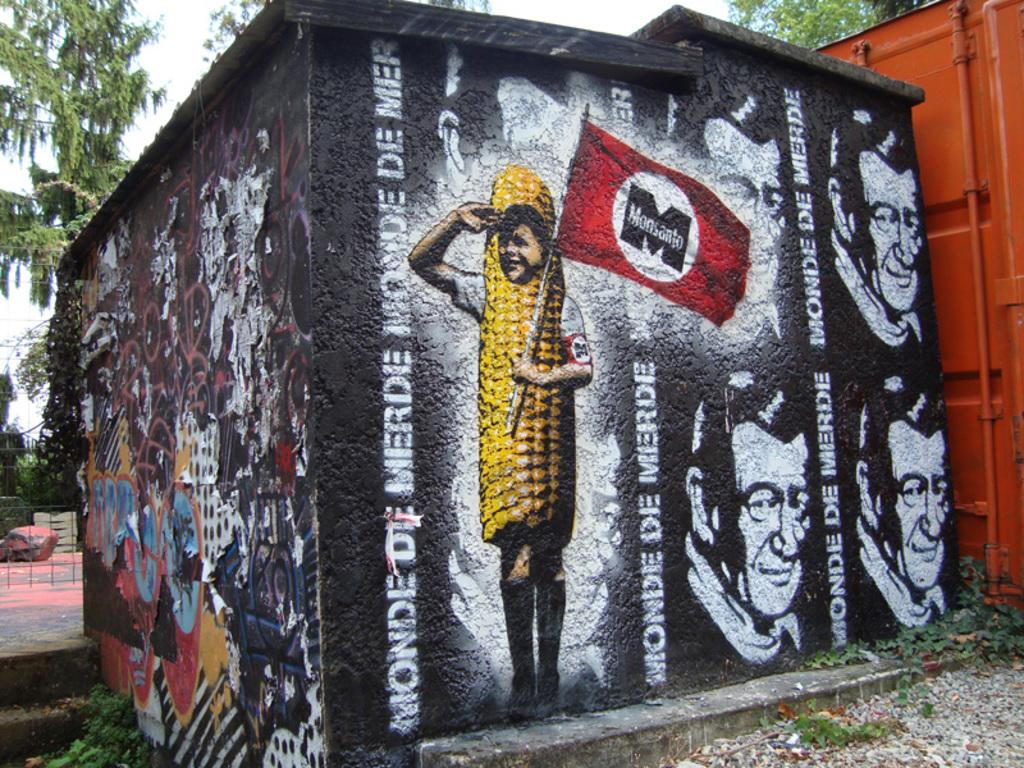What type of structure is present in the image? There is a shed in the image. What can be seen on the walls of the shed? The shed has paintings on its walls. What object in the image resembles a container? There is an object that looks like a container in the image. What type of vegetation is visible in the background of the image? There are trees in the background of the image. What safety feature is present in the image? There is railing in the image. What architectural element is present in the image? There are stairs in the image. What part of the natural environment is visible in the background of the image? The sky is visible in the background of the image. What type of plants are growing on the net in the image? There is no net or plants present in the image. 